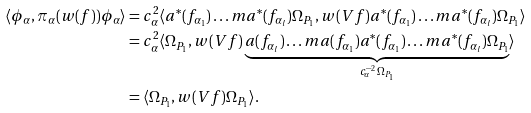Convert formula to latex. <formula><loc_0><loc_0><loc_500><loc_500>\langle { \phi _ { \alpha } , \pi _ { \alpha } ( w ( f ) ) \phi _ { \alpha } } \rangle & = c _ { \alpha } ^ { 2 } \langle { a ^ { * } ( f _ { \alpha _ { 1 } } ) \dots m a ^ { * } ( f _ { \alpha _ { l } } ) \Omega _ { P _ { 1 } } , w ( V f ) a ^ { * } ( f _ { \alpha _ { 1 } } ) \dots m a ^ { * } ( f _ { \alpha _ { l } } ) \Omega _ { P _ { 1 } } } \rangle \\ & = c _ { \alpha } ^ { 2 } \langle \Omega _ { P _ { 1 } } , w ( V f ) \underbrace { a ( f _ { \alpha _ { l } } ) \dots m a ( f _ { \alpha _ { 1 } } ) a ^ { * } ( f _ { \alpha _ { 1 } } ) \dots m a ^ { * } ( f _ { \alpha _ { l } } ) \Omega _ { P _ { 1 } } } _ { c _ { \alpha } ^ { - 2 } \Omega _ { P _ { 1 } } } \rangle \\ & = \langle { \Omega _ { P _ { 1 } } , w ( V f ) \Omega _ { P _ { 1 } } } \rangle .</formula> 